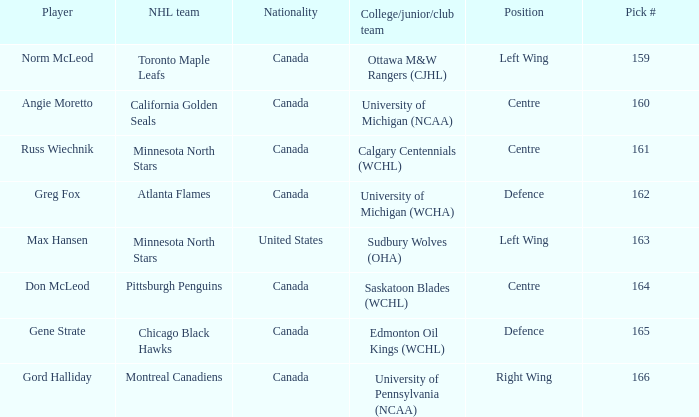How many players have the pick number 166? 1.0. 